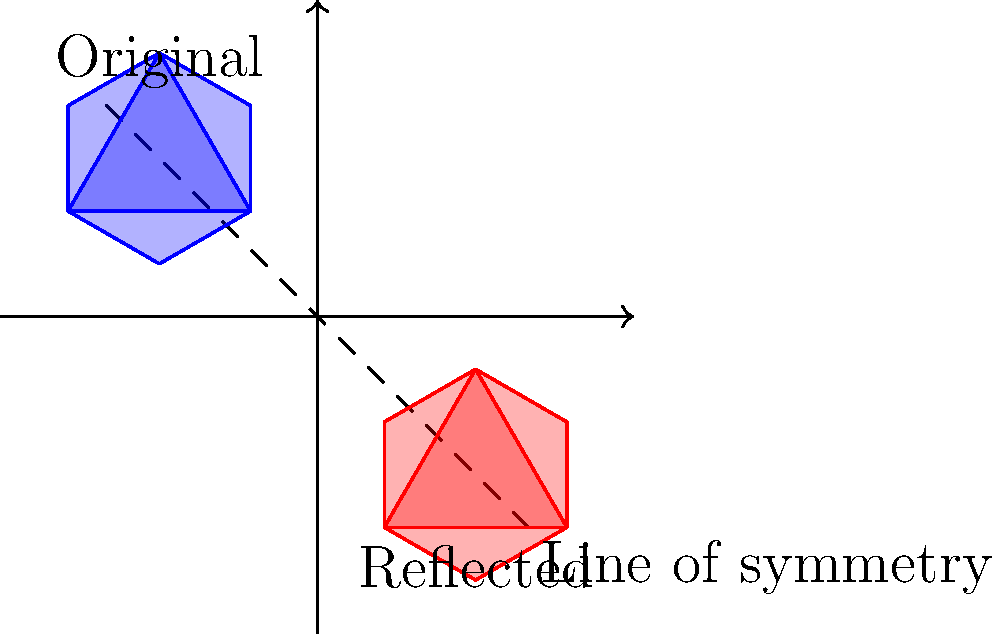A Star of David is reflected across a line of symmetry as shown in the figure. If the coordinates of point A on the original Star of David are $(-1.5, 2.5)$, what are the coordinates of the corresponding point A' on the reflected Star of David? To find the coordinates of the reflected point A', we can follow these steps:

1) The line of symmetry is given by the equation $y = -x$.

2) To reflect a point $(x, y)$ across the line $y = -x$, we use the reflection formula:
   $$(x', y') = (y, x)$$

3) The original point A has coordinates $(-1.5, 2.5)$.

4) Applying the reflection formula:
   $x' = 2.5$
   $y' = -1.5$

5) Therefore, the coordinates of the reflected point A' are $(2.5, -1.5)$.

This reflection maintains the shape and size of the Star of David while changing its position and orientation, demonstrating the principle of congruence in transformational geometry.
Answer: $(2.5, -1.5)$ 